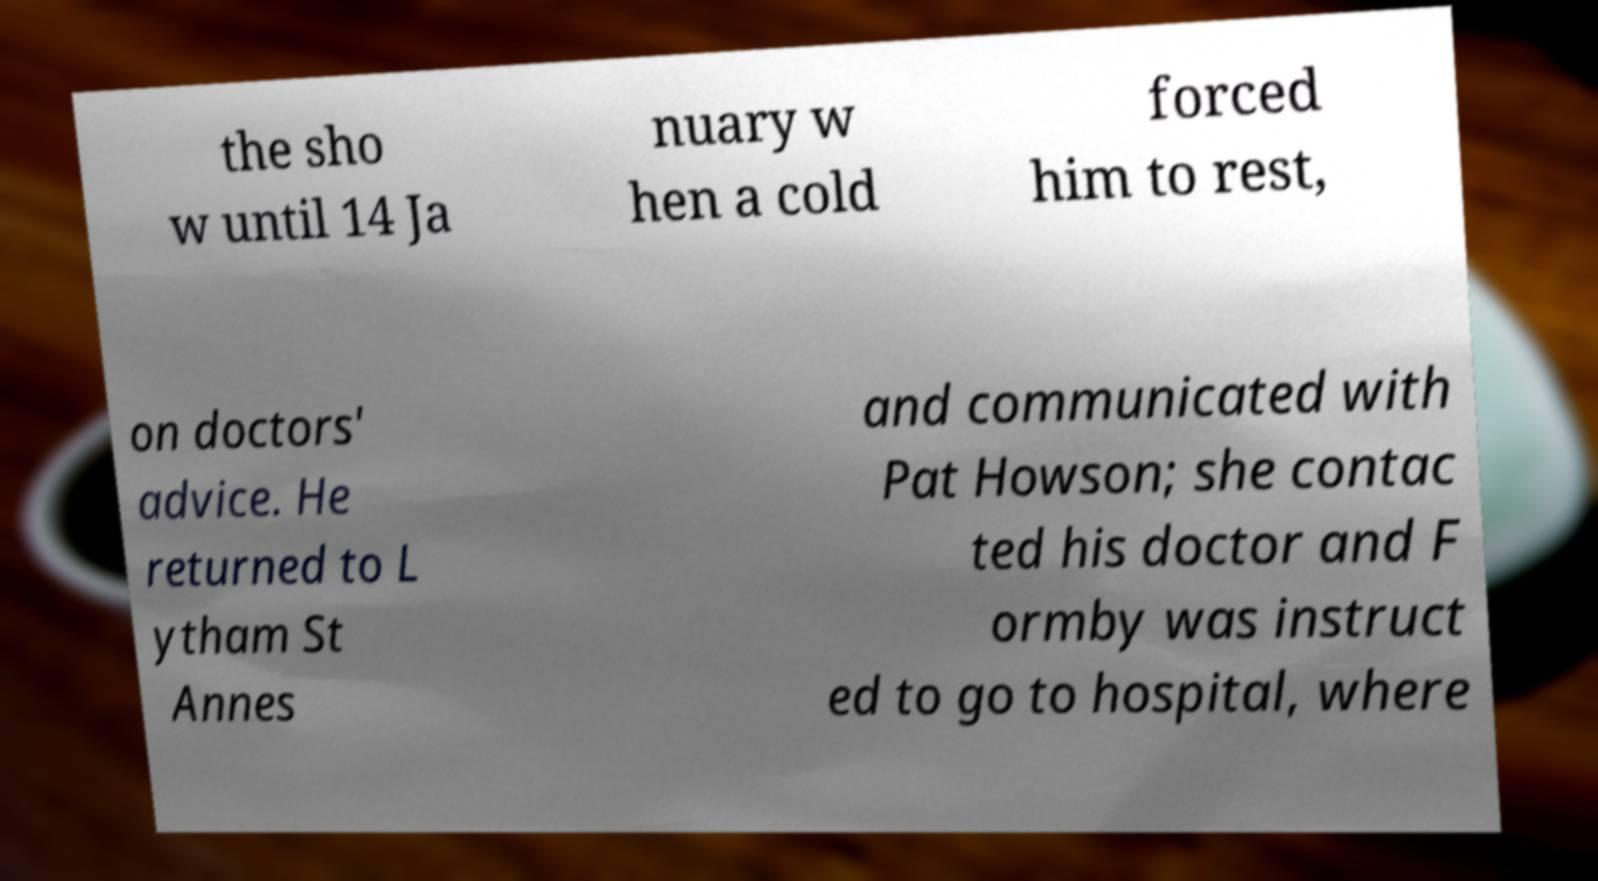What messages or text are displayed in this image? I need them in a readable, typed format. the sho w until 14 Ja nuary w hen a cold forced him to rest, on doctors' advice. He returned to L ytham St Annes and communicated with Pat Howson; she contac ted his doctor and F ormby was instruct ed to go to hospital, where 